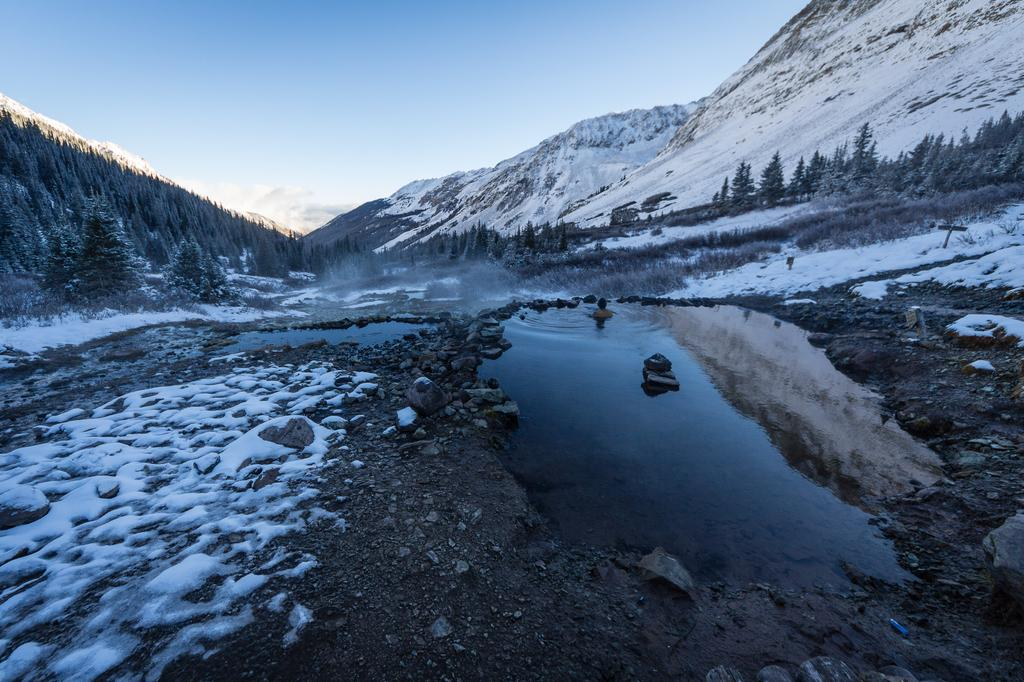What type of body of water is present in the image? There is a pond in the image. What type of vegetation can be seen in the image? There are trees in the image. What type of geographical feature is visible in the background? There are mountains in the image. What is visible at the top of the image? The sky is visible at the top of the image. How many fingers can be seen in the image? There are no fingers visible in the image. What type of meeting is taking place in the image? There is no meeting present in the image. 